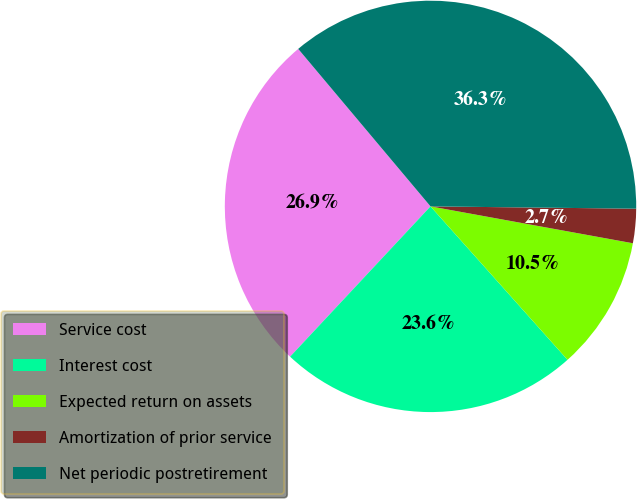<chart> <loc_0><loc_0><loc_500><loc_500><pie_chart><fcel>Service cost<fcel>Interest cost<fcel>Expected return on assets<fcel>Amortization of prior service<fcel>Net periodic postretirement<nl><fcel>26.92%<fcel>23.56%<fcel>10.53%<fcel>2.69%<fcel>36.3%<nl></chart> 